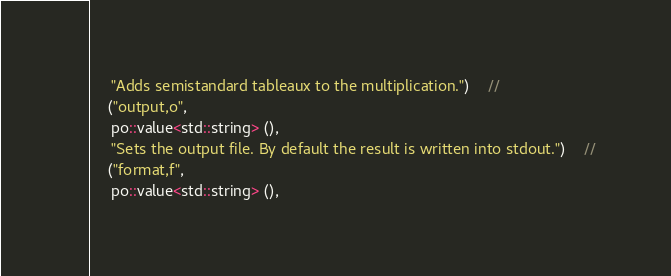Convert code to text. <code><loc_0><loc_0><loc_500><loc_500><_C++_>     "Adds semistandard tableaux to the multiplication.")    //
    ("output,o",
     po::value<std::string> (),
     "Sets the output file. By default the result is written into stdout.")    //
    ("format,f",
     po::value<std::string> (),</code> 